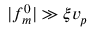<formula> <loc_0><loc_0><loc_500><loc_500>| f _ { m } ^ { 0 } | \gg \xi v _ { p }</formula> 